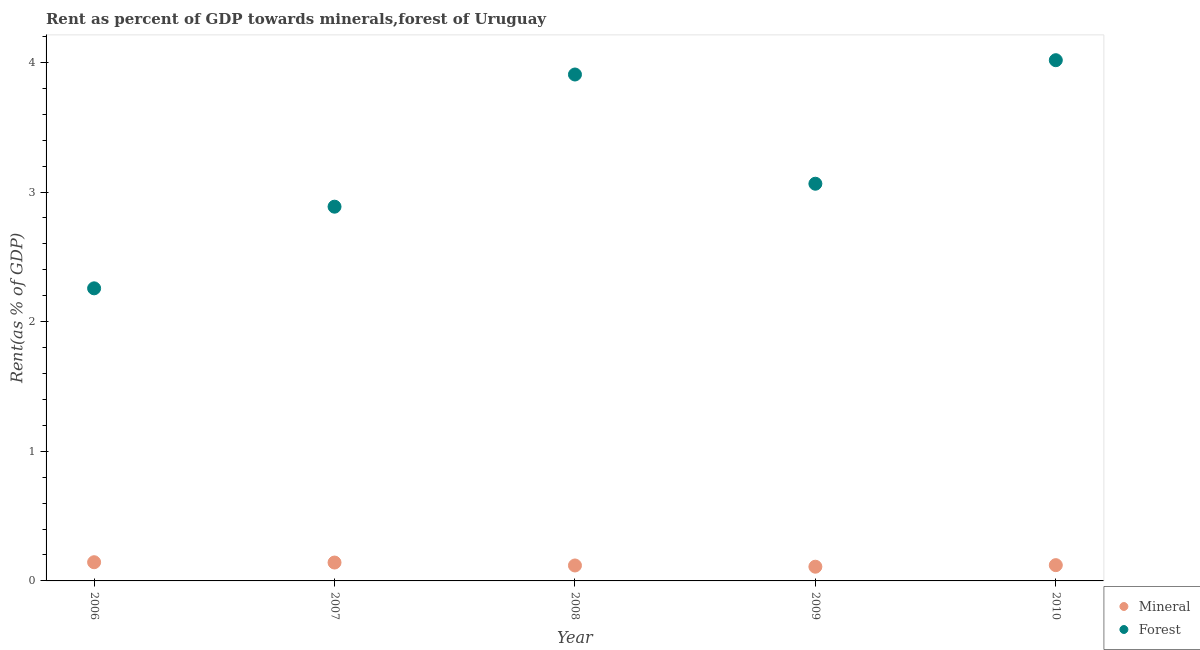How many different coloured dotlines are there?
Provide a succinct answer. 2. What is the mineral rent in 2007?
Provide a short and direct response. 0.14. Across all years, what is the maximum mineral rent?
Provide a succinct answer. 0.14. Across all years, what is the minimum forest rent?
Offer a terse response. 2.26. In which year was the forest rent maximum?
Your response must be concise. 2010. In which year was the mineral rent minimum?
Ensure brevity in your answer.  2009. What is the total forest rent in the graph?
Provide a short and direct response. 16.13. What is the difference between the forest rent in 2007 and that in 2009?
Keep it short and to the point. -0.18. What is the difference between the mineral rent in 2010 and the forest rent in 2008?
Offer a terse response. -3.79. What is the average forest rent per year?
Keep it short and to the point. 3.23. In the year 2006, what is the difference between the forest rent and mineral rent?
Your answer should be compact. 2.11. What is the ratio of the forest rent in 2007 to that in 2010?
Offer a terse response. 0.72. Is the forest rent in 2006 less than that in 2010?
Your answer should be compact. Yes. What is the difference between the highest and the second highest forest rent?
Your answer should be very brief. 0.11. What is the difference between the highest and the lowest forest rent?
Offer a very short reply. 1.76. In how many years, is the mineral rent greater than the average mineral rent taken over all years?
Give a very brief answer. 2. Is the forest rent strictly less than the mineral rent over the years?
Your answer should be compact. No. How many years are there in the graph?
Your answer should be very brief. 5. Does the graph contain grids?
Give a very brief answer. No. What is the title of the graph?
Provide a succinct answer. Rent as percent of GDP towards minerals,forest of Uruguay. What is the label or title of the Y-axis?
Make the answer very short. Rent(as % of GDP). What is the Rent(as % of GDP) in Mineral in 2006?
Offer a terse response. 0.14. What is the Rent(as % of GDP) in Forest in 2006?
Offer a terse response. 2.26. What is the Rent(as % of GDP) of Mineral in 2007?
Make the answer very short. 0.14. What is the Rent(as % of GDP) in Forest in 2007?
Offer a very short reply. 2.89. What is the Rent(as % of GDP) in Mineral in 2008?
Ensure brevity in your answer.  0.12. What is the Rent(as % of GDP) in Forest in 2008?
Offer a very short reply. 3.91. What is the Rent(as % of GDP) in Mineral in 2009?
Your answer should be compact. 0.11. What is the Rent(as % of GDP) in Forest in 2009?
Ensure brevity in your answer.  3.06. What is the Rent(as % of GDP) of Mineral in 2010?
Your response must be concise. 0.12. What is the Rent(as % of GDP) in Forest in 2010?
Keep it short and to the point. 4.02. Across all years, what is the maximum Rent(as % of GDP) of Mineral?
Give a very brief answer. 0.14. Across all years, what is the maximum Rent(as % of GDP) in Forest?
Offer a terse response. 4.02. Across all years, what is the minimum Rent(as % of GDP) in Mineral?
Ensure brevity in your answer.  0.11. Across all years, what is the minimum Rent(as % of GDP) of Forest?
Provide a short and direct response. 2.26. What is the total Rent(as % of GDP) of Mineral in the graph?
Your response must be concise. 0.64. What is the total Rent(as % of GDP) in Forest in the graph?
Your response must be concise. 16.13. What is the difference between the Rent(as % of GDP) in Mineral in 2006 and that in 2007?
Provide a succinct answer. 0. What is the difference between the Rent(as % of GDP) in Forest in 2006 and that in 2007?
Provide a succinct answer. -0.63. What is the difference between the Rent(as % of GDP) in Mineral in 2006 and that in 2008?
Your response must be concise. 0.03. What is the difference between the Rent(as % of GDP) in Forest in 2006 and that in 2008?
Provide a succinct answer. -1.65. What is the difference between the Rent(as % of GDP) of Mineral in 2006 and that in 2009?
Give a very brief answer. 0.03. What is the difference between the Rent(as % of GDP) in Forest in 2006 and that in 2009?
Your answer should be compact. -0.81. What is the difference between the Rent(as % of GDP) of Mineral in 2006 and that in 2010?
Your answer should be very brief. 0.02. What is the difference between the Rent(as % of GDP) of Forest in 2006 and that in 2010?
Keep it short and to the point. -1.76. What is the difference between the Rent(as % of GDP) of Mineral in 2007 and that in 2008?
Keep it short and to the point. 0.02. What is the difference between the Rent(as % of GDP) of Forest in 2007 and that in 2008?
Offer a very short reply. -1.02. What is the difference between the Rent(as % of GDP) of Mineral in 2007 and that in 2009?
Make the answer very short. 0.03. What is the difference between the Rent(as % of GDP) in Forest in 2007 and that in 2009?
Offer a terse response. -0.18. What is the difference between the Rent(as % of GDP) of Mineral in 2007 and that in 2010?
Provide a short and direct response. 0.02. What is the difference between the Rent(as % of GDP) of Forest in 2007 and that in 2010?
Keep it short and to the point. -1.13. What is the difference between the Rent(as % of GDP) of Mineral in 2008 and that in 2009?
Make the answer very short. 0.01. What is the difference between the Rent(as % of GDP) in Forest in 2008 and that in 2009?
Ensure brevity in your answer.  0.84. What is the difference between the Rent(as % of GDP) in Mineral in 2008 and that in 2010?
Offer a very short reply. -0. What is the difference between the Rent(as % of GDP) in Forest in 2008 and that in 2010?
Provide a short and direct response. -0.11. What is the difference between the Rent(as % of GDP) of Mineral in 2009 and that in 2010?
Make the answer very short. -0.01. What is the difference between the Rent(as % of GDP) in Forest in 2009 and that in 2010?
Your response must be concise. -0.95. What is the difference between the Rent(as % of GDP) in Mineral in 2006 and the Rent(as % of GDP) in Forest in 2007?
Keep it short and to the point. -2.74. What is the difference between the Rent(as % of GDP) in Mineral in 2006 and the Rent(as % of GDP) in Forest in 2008?
Your response must be concise. -3.76. What is the difference between the Rent(as % of GDP) of Mineral in 2006 and the Rent(as % of GDP) of Forest in 2009?
Ensure brevity in your answer.  -2.92. What is the difference between the Rent(as % of GDP) in Mineral in 2006 and the Rent(as % of GDP) in Forest in 2010?
Provide a succinct answer. -3.87. What is the difference between the Rent(as % of GDP) of Mineral in 2007 and the Rent(as % of GDP) of Forest in 2008?
Your response must be concise. -3.77. What is the difference between the Rent(as % of GDP) of Mineral in 2007 and the Rent(as % of GDP) of Forest in 2009?
Your answer should be compact. -2.92. What is the difference between the Rent(as % of GDP) of Mineral in 2007 and the Rent(as % of GDP) of Forest in 2010?
Offer a very short reply. -3.88. What is the difference between the Rent(as % of GDP) of Mineral in 2008 and the Rent(as % of GDP) of Forest in 2009?
Offer a terse response. -2.95. What is the difference between the Rent(as % of GDP) of Mineral in 2008 and the Rent(as % of GDP) of Forest in 2010?
Offer a terse response. -3.9. What is the difference between the Rent(as % of GDP) of Mineral in 2009 and the Rent(as % of GDP) of Forest in 2010?
Your response must be concise. -3.91. What is the average Rent(as % of GDP) in Mineral per year?
Your answer should be very brief. 0.13. What is the average Rent(as % of GDP) of Forest per year?
Make the answer very short. 3.23. In the year 2006, what is the difference between the Rent(as % of GDP) in Mineral and Rent(as % of GDP) in Forest?
Make the answer very short. -2.11. In the year 2007, what is the difference between the Rent(as % of GDP) of Mineral and Rent(as % of GDP) of Forest?
Give a very brief answer. -2.75. In the year 2008, what is the difference between the Rent(as % of GDP) in Mineral and Rent(as % of GDP) in Forest?
Your response must be concise. -3.79. In the year 2009, what is the difference between the Rent(as % of GDP) in Mineral and Rent(as % of GDP) in Forest?
Make the answer very short. -2.95. In the year 2010, what is the difference between the Rent(as % of GDP) in Mineral and Rent(as % of GDP) in Forest?
Keep it short and to the point. -3.9. What is the ratio of the Rent(as % of GDP) of Mineral in 2006 to that in 2007?
Your response must be concise. 1.02. What is the ratio of the Rent(as % of GDP) of Forest in 2006 to that in 2007?
Your answer should be very brief. 0.78. What is the ratio of the Rent(as % of GDP) of Mineral in 2006 to that in 2008?
Make the answer very short. 1.21. What is the ratio of the Rent(as % of GDP) in Forest in 2006 to that in 2008?
Provide a succinct answer. 0.58. What is the ratio of the Rent(as % of GDP) in Mineral in 2006 to that in 2009?
Provide a short and direct response. 1.32. What is the ratio of the Rent(as % of GDP) in Forest in 2006 to that in 2009?
Your answer should be compact. 0.74. What is the ratio of the Rent(as % of GDP) of Mineral in 2006 to that in 2010?
Give a very brief answer. 1.19. What is the ratio of the Rent(as % of GDP) in Forest in 2006 to that in 2010?
Ensure brevity in your answer.  0.56. What is the ratio of the Rent(as % of GDP) in Mineral in 2007 to that in 2008?
Offer a very short reply. 1.19. What is the ratio of the Rent(as % of GDP) of Forest in 2007 to that in 2008?
Make the answer very short. 0.74. What is the ratio of the Rent(as % of GDP) of Mineral in 2007 to that in 2009?
Provide a succinct answer. 1.29. What is the ratio of the Rent(as % of GDP) of Forest in 2007 to that in 2009?
Make the answer very short. 0.94. What is the ratio of the Rent(as % of GDP) of Mineral in 2007 to that in 2010?
Give a very brief answer. 1.17. What is the ratio of the Rent(as % of GDP) of Forest in 2007 to that in 2010?
Provide a short and direct response. 0.72. What is the ratio of the Rent(as % of GDP) of Mineral in 2008 to that in 2009?
Offer a very short reply. 1.09. What is the ratio of the Rent(as % of GDP) in Forest in 2008 to that in 2009?
Keep it short and to the point. 1.27. What is the ratio of the Rent(as % of GDP) of Mineral in 2008 to that in 2010?
Give a very brief answer. 0.98. What is the ratio of the Rent(as % of GDP) of Forest in 2008 to that in 2010?
Keep it short and to the point. 0.97. What is the ratio of the Rent(as % of GDP) of Mineral in 2009 to that in 2010?
Keep it short and to the point. 0.9. What is the ratio of the Rent(as % of GDP) of Forest in 2009 to that in 2010?
Your answer should be compact. 0.76. What is the difference between the highest and the second highest Rent(as % of GDP) of Mineral?
Your answer should be compact. 0. What is the difference between the highest and the second highest Rent(as % of GDP) of Forest?
Your response must be concise. 0.11. What is the difference between the highest and the lowest Rent(as % of GDP) of Mineral?
Your answer should be compact. 0.03. What is the difference between the highest and the lowest Rent(as % of GDP) of Forest?
Give a very brief answer. 1.76. 